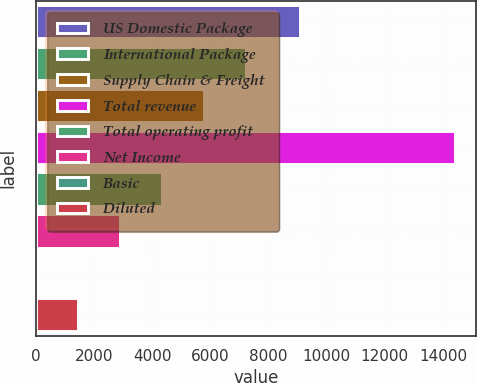Convert chart. <chart><loc_0><loc_0><loc_500><loc_500><bar_chart><fcel>US Domestic Package<fcel>International Package<fcel>Supply Chain & Freight<fcel>Total revenue<fcel>Total operating profit<fcel>Net Income<fcel>Basic<fcel>Diluted<nl><fcel>9084<fcel>7209.62<fcel>5767.95<fcel>14418<fcel>4326.28<fcel>2884.61<fcel>1.27<fcel>1442.94<nl></chart> 